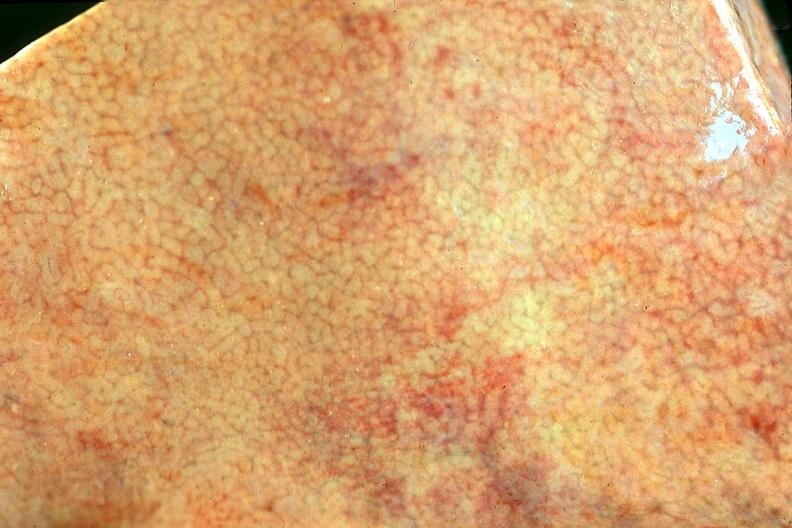does normal ovary show normal liver?
Answer the question using a single word or phrase. No 